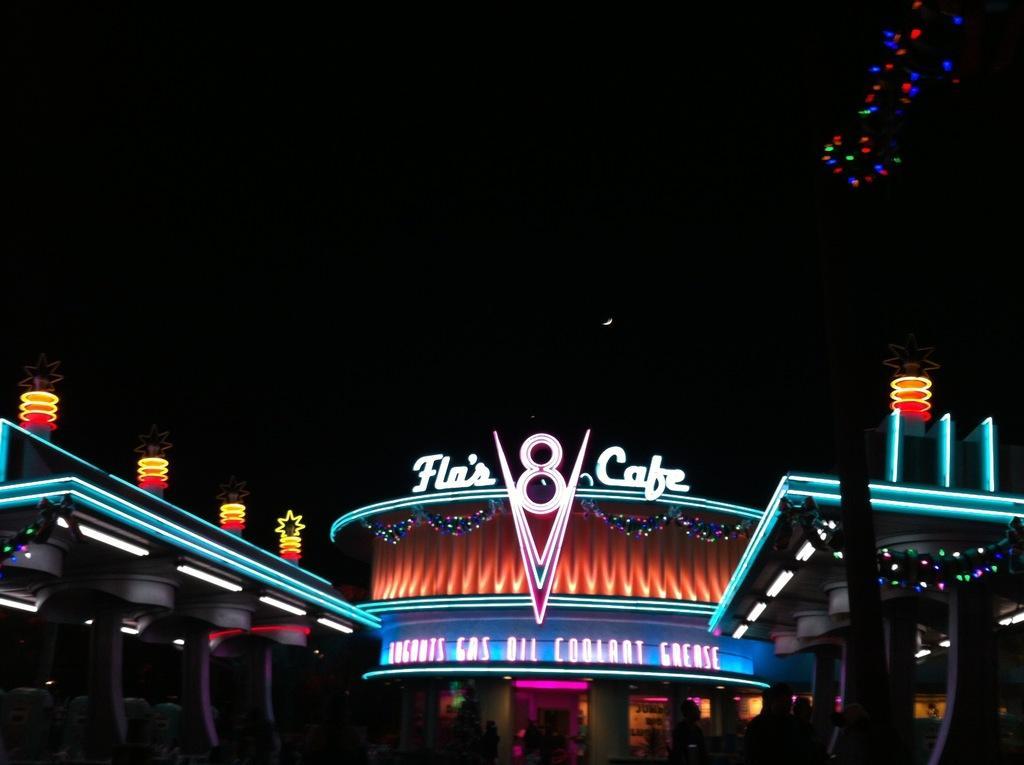Could you give a brief overview of what you see in this image? There is a building which has an acrylic hoarding named ' flos 8 cafe'. 